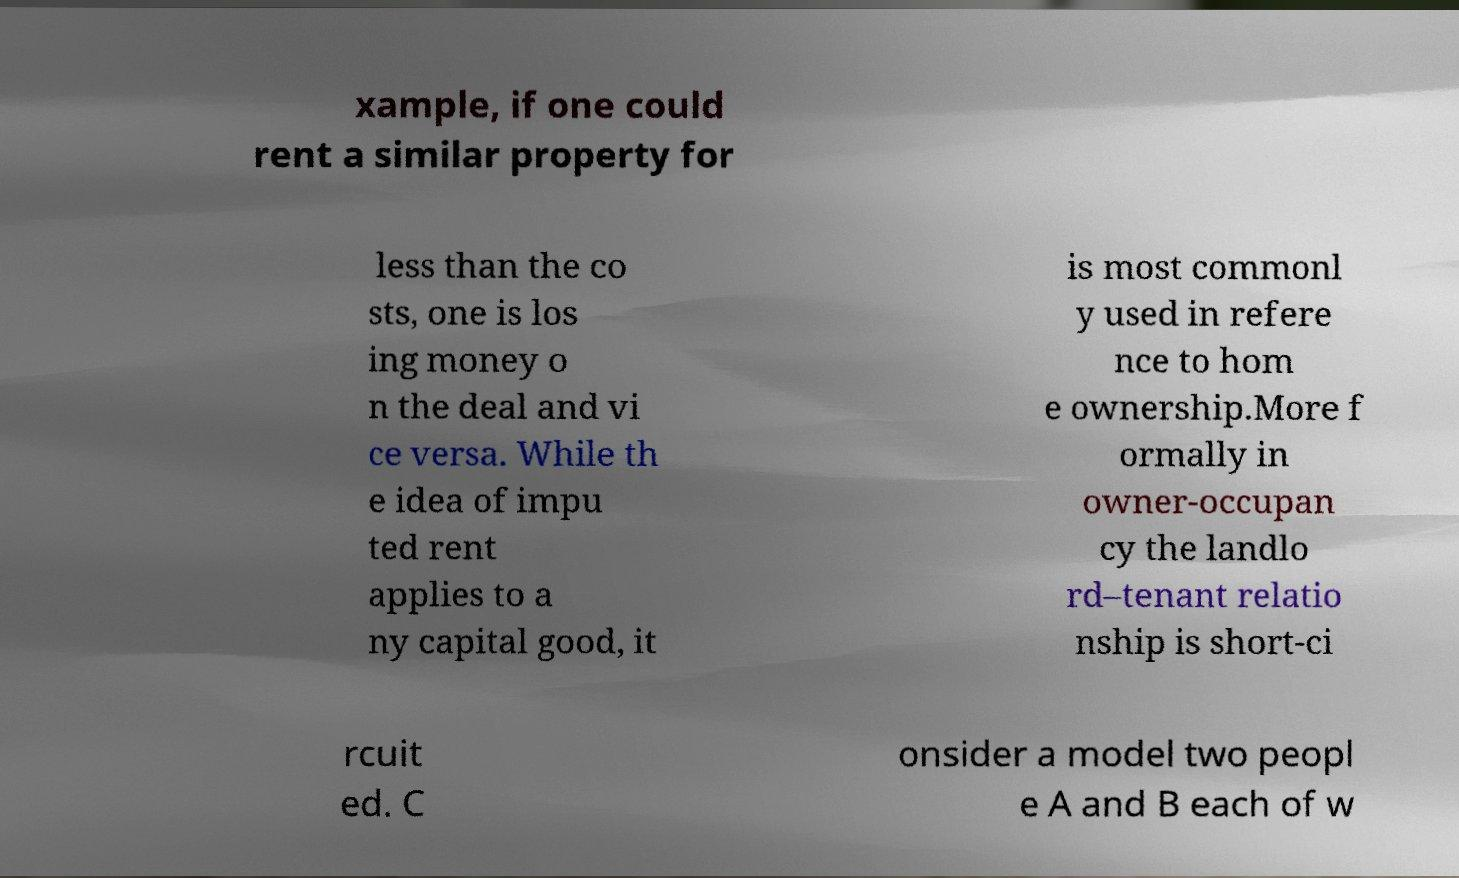Please read and relay the text visible in this image. What does it say? xample, if one could rent a similar property for less than the co sts, one is los ing money o n the deal and vi ce versa. While th e idea of impu ted rent applies to a ny capital good, it is most commonl y used in refere nce to hom e ownership.More f ormally in owner-occupan cy the landlo rd–tenant relatio nship is short-ci rcuit ed. C onsider a model two peopl e A and B each of w 